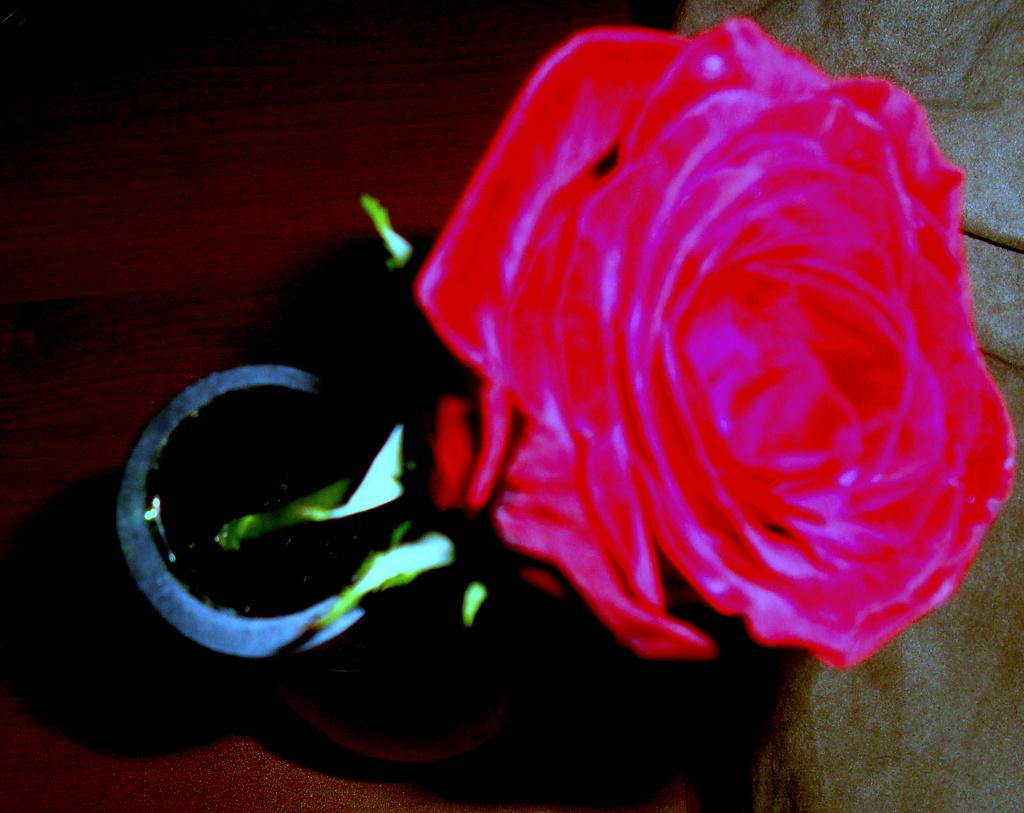What type of flower is in the image? There is a rose flower in the image. Can you describe any other objects in the image besides the flower? Unfortunately, the provided facts only mention that there are objects in the image, but no specific details are given about them. What type of vegetable is growing next to the rose flower in the image? There is no vegetable present in the image; only a rose flower is mentioned. Can you tell me how many stars are visible in the image? There is no mention of stars in the image, so it is not possible to determine their presence or quantity. 